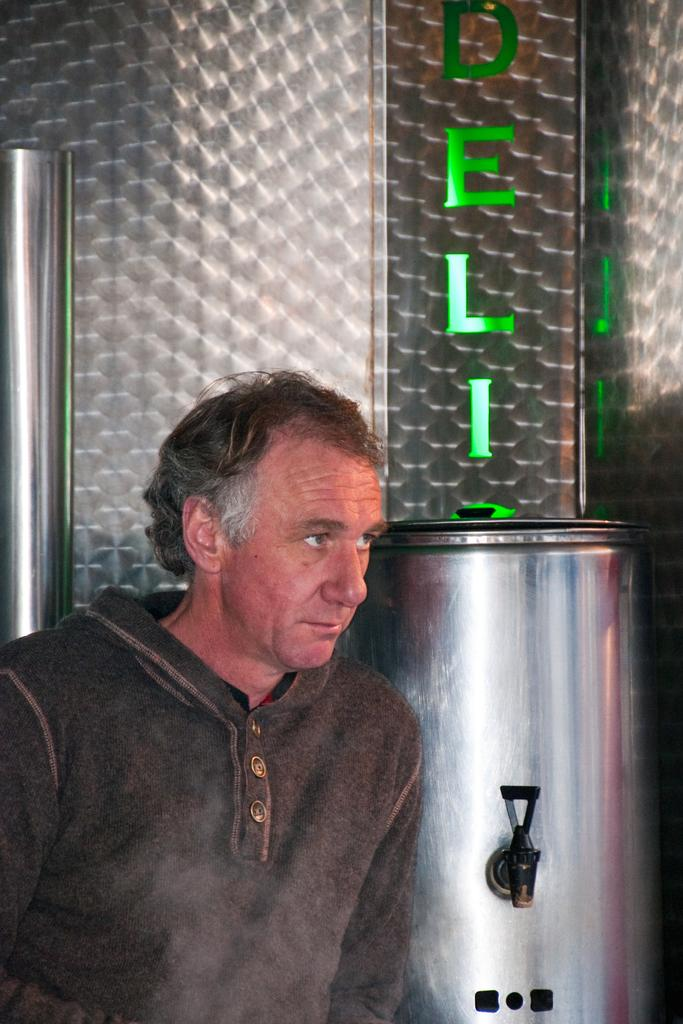<image>
Create a compact narrative representing the image presented. A man stands near a green Deli sign over a drink dispenser. 